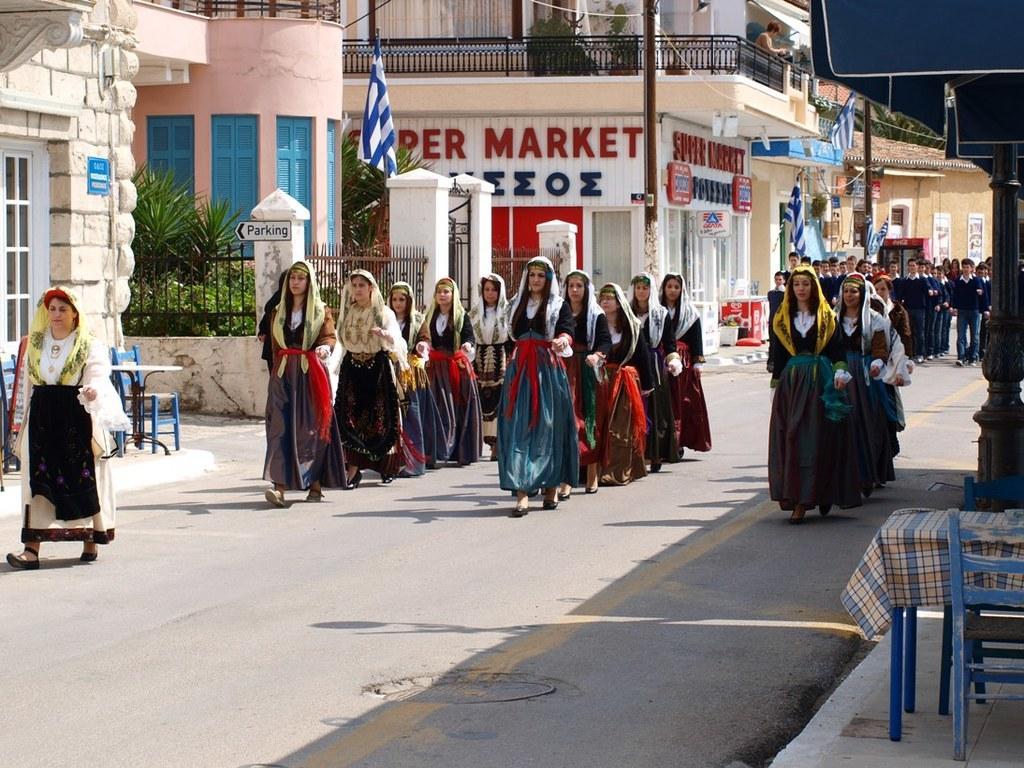Could you give a brief overview of what you see in this image? There is a group of persons standing in the middle of this image and there are some buildings in the background. There is a road at the bottom of this image. 